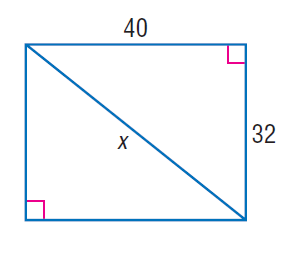Question: Find x.
Choices:
A. 24
B. 32
C. 40
D. 8 \sqrt { 41 }
Answer with the letter. Answer: D 